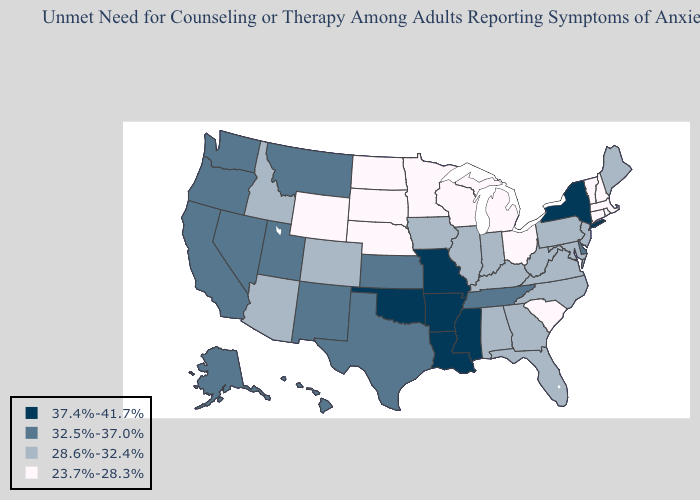Does Kansas have a lower value than Wyoming?
Answer briefly. No. What is the lowest value in the South?
Concise answer only. 23.7%-28.3%. Does Rhode Island have the lowest value in the Northeast?
Quick response, please. Yes. Which states hav the highest value in the South?
Write a very short answer. Arkansas, Louisiana, Mississippi, Oklahoma. Does the first symbol in the legend represent the smallest category?
Short answer required. No. Does Kansas have the same value as Tennessee?
Give a very brief answer. Yes. Does Tennessee have the lowest value in the South?
Keep it brief. No. Is the legend a continuous bar?
Keep it brief. No. Name the states that have a value in the range 28.6%-32.4%?
Keep it brief. Alabama, Arizona, Colorado, Florida, Georgia, Idaho, Illinois, Indiana, Iowa, Kentucky, Maine, Maryland, New Jersey, North Carolina, Pennsylvania, Virginia, West Virginia. What is the value of Nebraska?
Write a very short answer. 23.7%-28.3%. What is the value of Texas?
Concise answer only. 32.5%-37.0%. Name the states that have a value in the range 32.5%-37.0%?
Be succinct. Alaska, California, Delaware, Hawaii, Kansas, Montana, Nevada, New Mexico, Oregon, Tennessee, Texas, Utah, Washington. Among the states that border Kansas , which have the lowest value?
Concise answer only. Nebraska. What is the lowest value in the USA?
Concise answer only. 23.7%-28.3%. What is the lowest value in states that border Arizona?
Answer briefly. 28.6%-32.4%. 